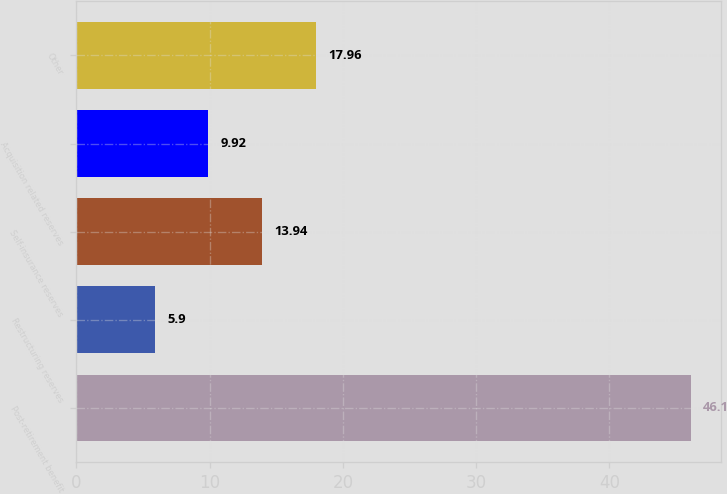Convert chart to OTSL. <chart><loc_0><loc_0><loc_500><loc_500><bar_chart><fcel>Post-retirement benefit<fcel>Restructuring reserves<fcel>Self-insurance reserves<fcel>Acquisition related reserves<fcel>Other<nl><fcel>46.1<fcel>5.9<fcel>13.94<fcel>9.92<fcel>17.96<nl></chart> 